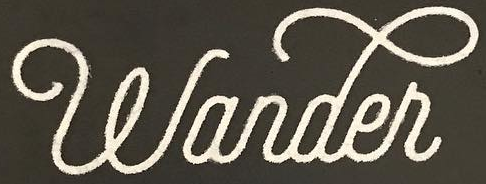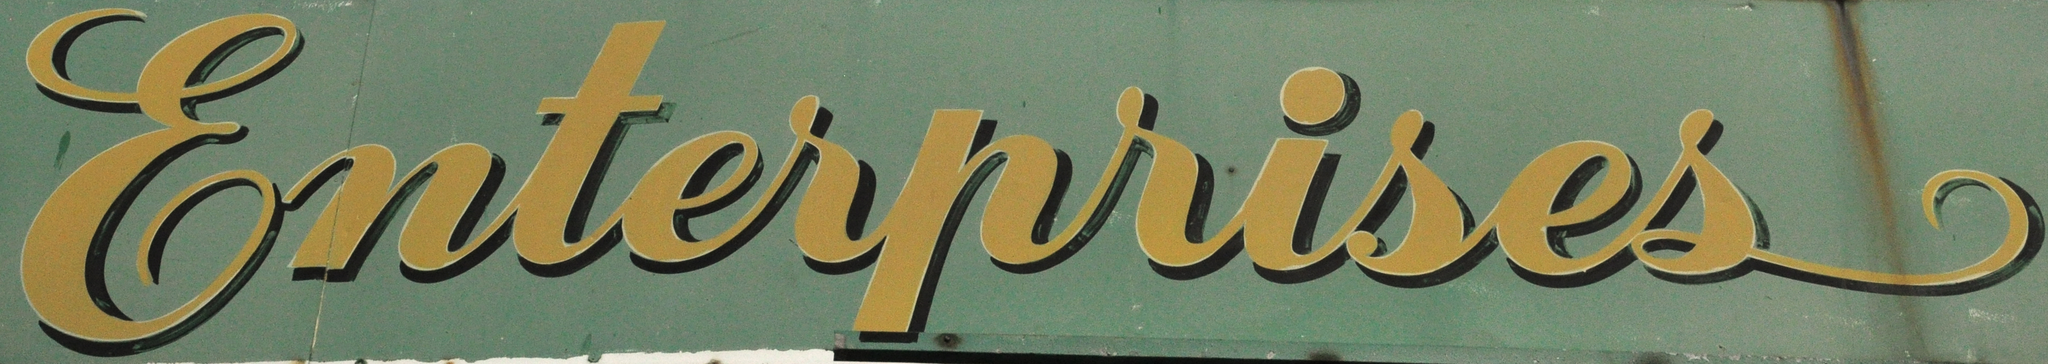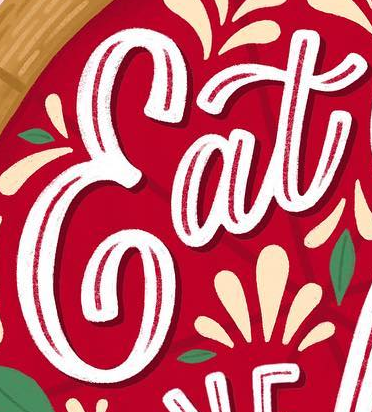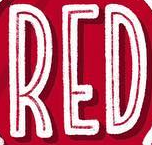What words are shown in these images in order, separated by a semicolon? wander; Enterprises; Eat; RED 